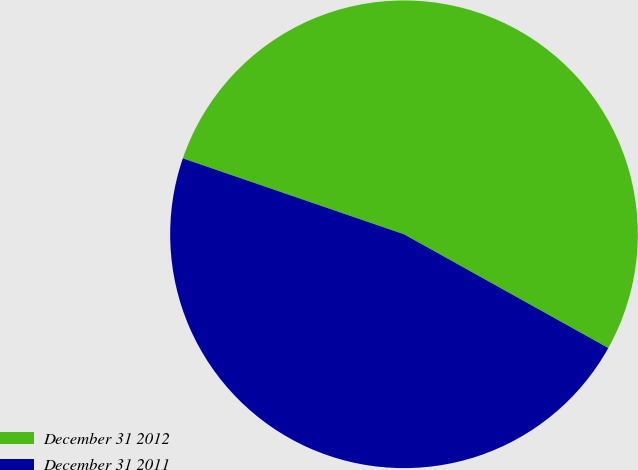Convert chart. <chart><loc_0><loc_0><loc_500><loc_500><pie_chart><fcel>December 31 2012<fcel>December 31 2011<nl><fcel>52.82%<fcel>47.18%<nl></chart> 